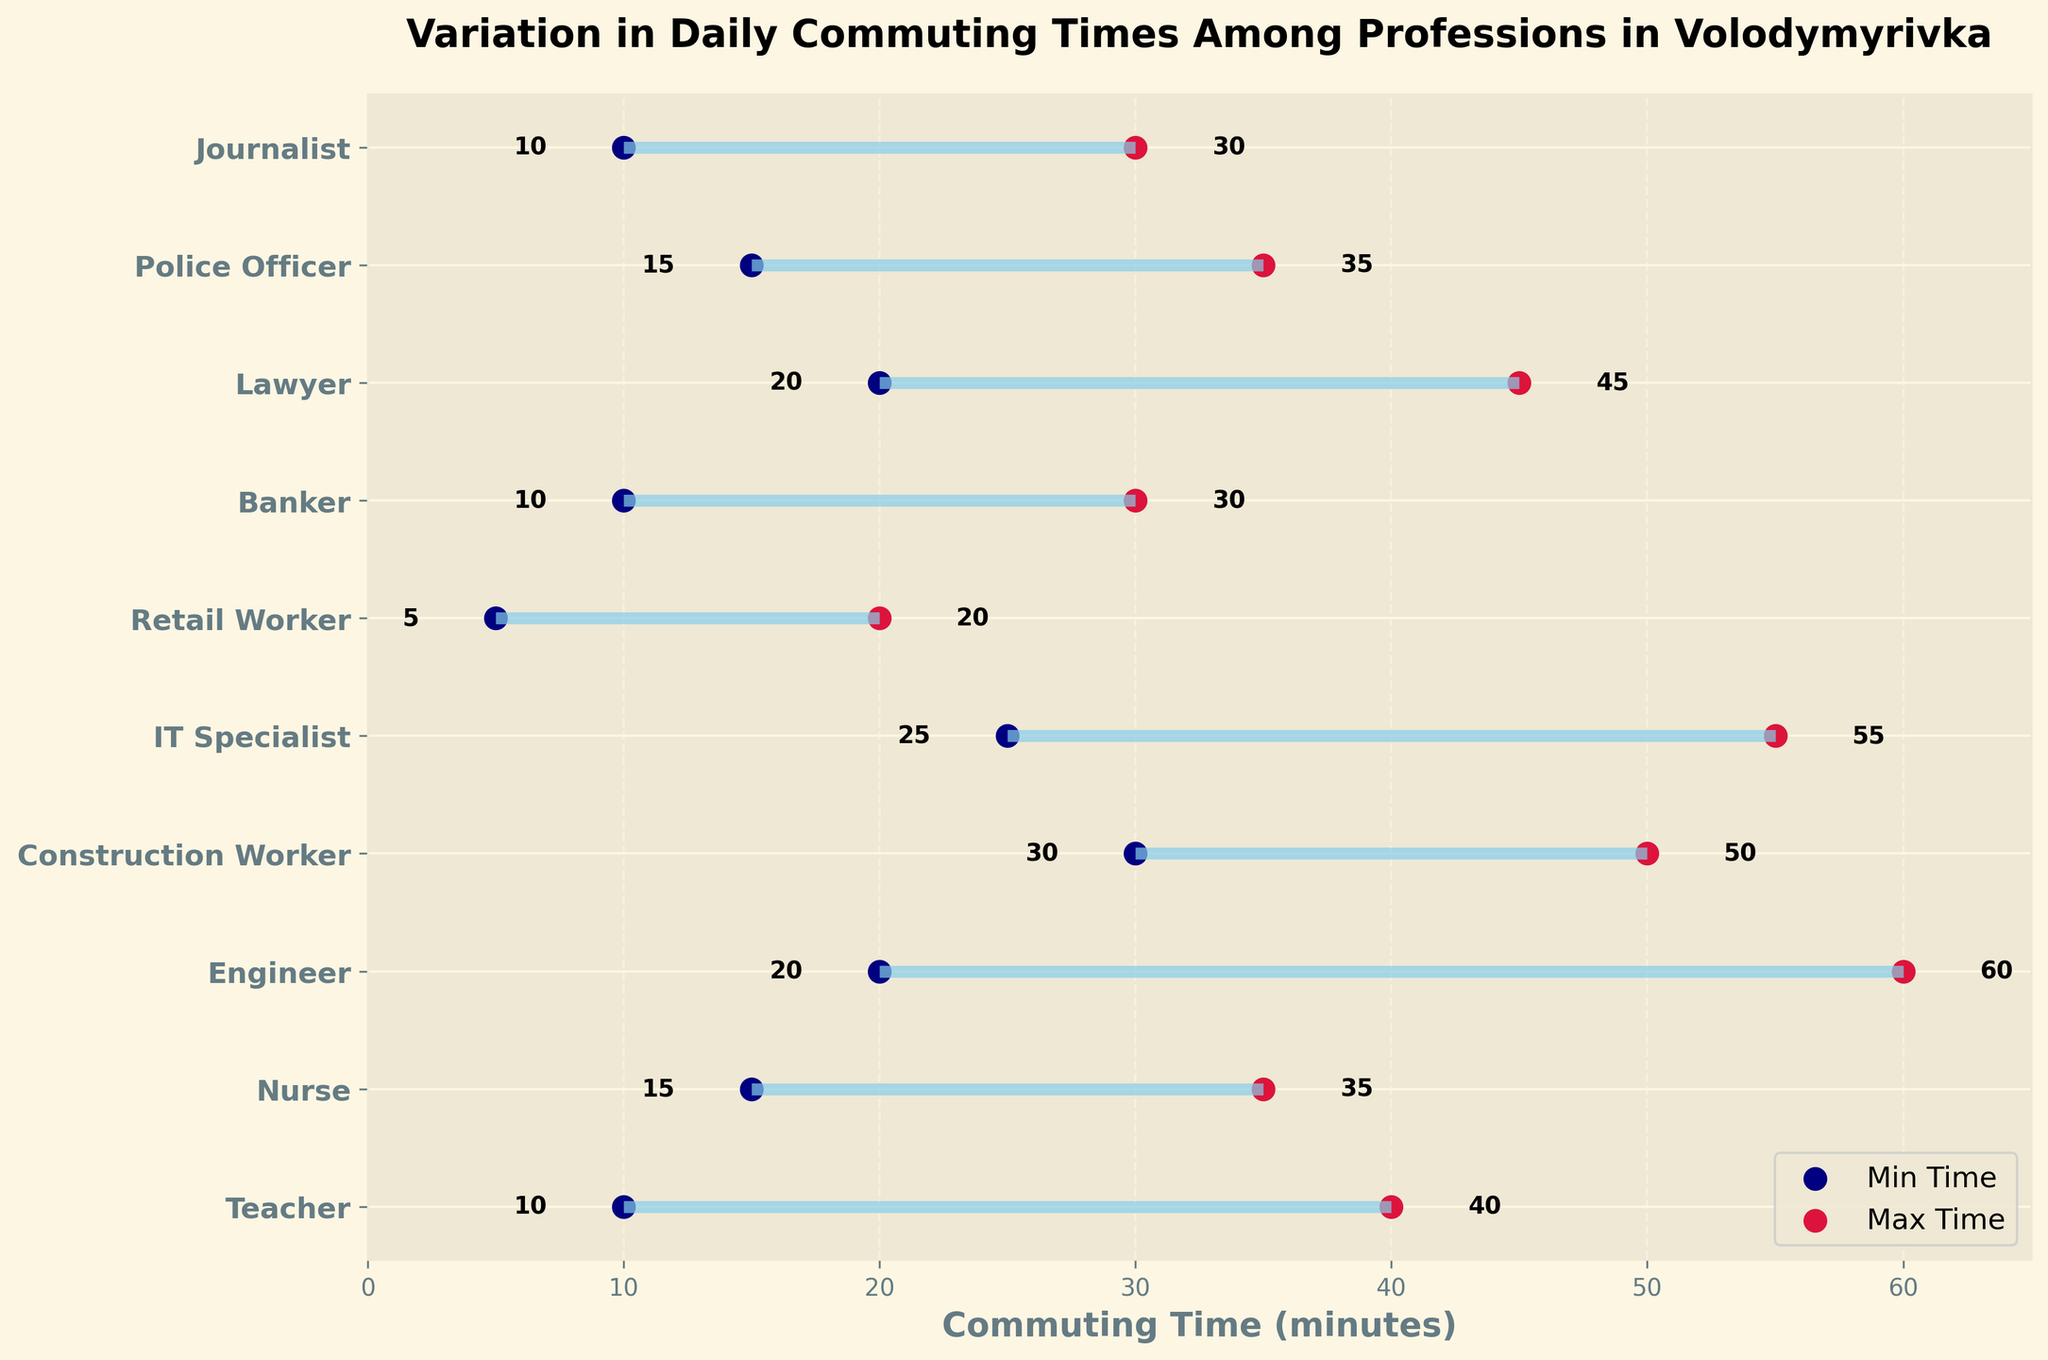What is the minimum commuting time for an IT Specialist? The minimum commuting time for an IT Specialist can be found by locating the IT Specialist on the y-axis and referring to the corresponding dot on the x-axis representing the minimum time.
Answer: 25 minutes What is the range of commuting times for Construction Workers? The range is the difference between the maximum and minimum commuting times. For Construction Workers, the maximum is 50 minutes and the minimum is 30 minutes. Subtract 30 from 50 to get the range.
Answer: 20 minutes Which profession has the smallest maximum commuting time? By looking at the maximum dot values for each profession, Retail Worker’s maximum is the smallest at 20 minutes.
Answer: Retail Worker How many professions have a minimum commuting time of 10 minutes? Look for dots on the minimum time axis that are positioned over 10 minutes and count the corresponding professions.
Answer: 3 professions (Teacher, Banker, Journalist) What is the average maximum commuting time among all professions? Sum all maximum commuting times and divide by the number of professions. (40 + 35 + 60 + 50 + 55 + 20 + 30 + 45 + 35 + 30) / 10 = 40
Answer: 40 minutes Which profession has the widest range of daily commuting times? Calculate the range for each profession by subtracting the minimum time from the maximum time and compare. The Engineer has the widest range with (60 - 20) = 40 minutes.
Answer: Engineer Is the maximum commuting time for Nurses greater than the minimum commuting time for Engineers? Compare the maximum time value for Nurses (35 minutes) with the minimum time value for Engineers (20 minutes). Since 35 > 20, the answer is yes.
Answer: Yes What is the title of the plot? The title is written at the top of the plot.
Answer: Variation in Daily Commuting Times Among Professions in Volodymyrivka For which profession is the difference between maximum and minimum commuting times equal to 20 minutes? Calculate the differences for each profession until you find the one that matches 20 minutes. The Construction Worker and Police Officer both fit.
Answer: Construction Worker, Police Officer 